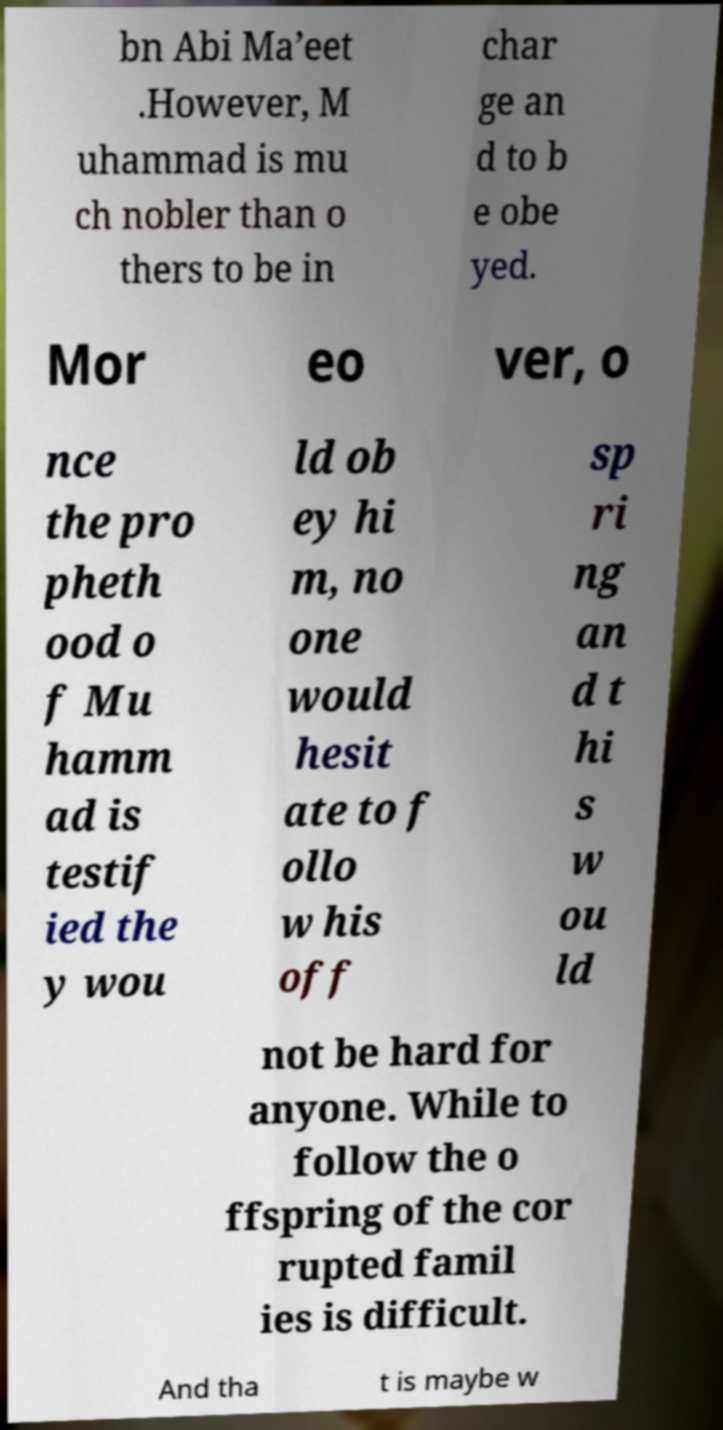I need the written content from this picture converted into text. Can you do that? bn Abi Ma’eet .However, M uhammad is mu ch nobler than o thers to be in char ge an d to b e obe yed. Mor eo ver, o nce the pro pheth ood o f Mu hamm ad is testif ied the y wou ld ob ey hi m, no one would hesit ate to f ollo w his off sp ri ng an d t hi s w ou ld not be hard for anyone. While to follow the o ffspring of the cor rupted famil ies is difficult. And tha t is maybe w 